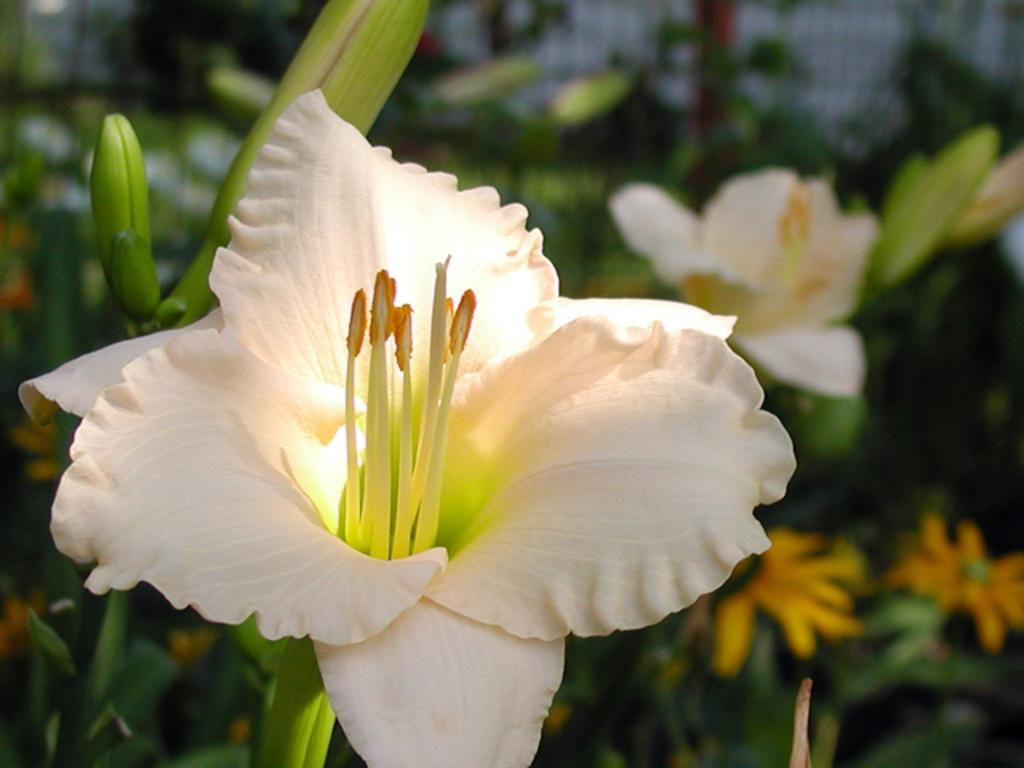What type of living organisms can be seen in the image? Flowers, buds, and plants can be seen in the image. Can you describe the growth stage of the plants in the image? The image shows both flowers and buds, indicating that the plants are in different stages of growth. What is the primary subject of the image? The primary subject of the image is the plants, which include flowers and buds. What type of grape is being harvested by the laborer at the party in the image? There is no grape, laborer, or party present in the image. The image only features flowers, buds, and plants. 